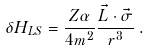Convert formula to latex. <formula><loc_0><loc_0><loc_500><loc_500>\delta H _ { L S } = \frac { Z \alpha } { 4 m ^ { 2 } } \frac { \vec { L } \cdot \vec { \sigma } } { r ^ { 3 } } \, .</formula> 